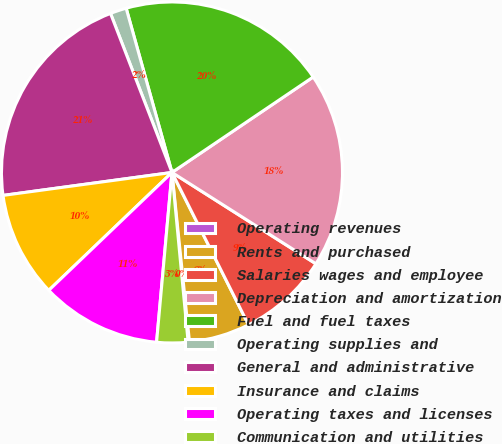Convert chart. <chart><loc_0><loc_0><loc_500><loc_500><pie_chart><fcel>Operating revenues<fcel>Rents and purchased<fcel>Salaries wages and employee<fcel>Depreciation and amortization<fcel>Fuel and fuel taxes<fcel>Operating supplies and<fcel>General and administrative<fcel>Insurance and claims<fcel>Operating taxes and licenses<fcel>Communication and utilities<nl><fcel>0.13%<fcel>5.77%<fcel>8.59%<fcel>18.46%<fcel>19.87%<fcel>1.54%<fcel>21.28%<fcel>10.0%<fcel>11.41%<fcel>2.95%<nl></chart> 